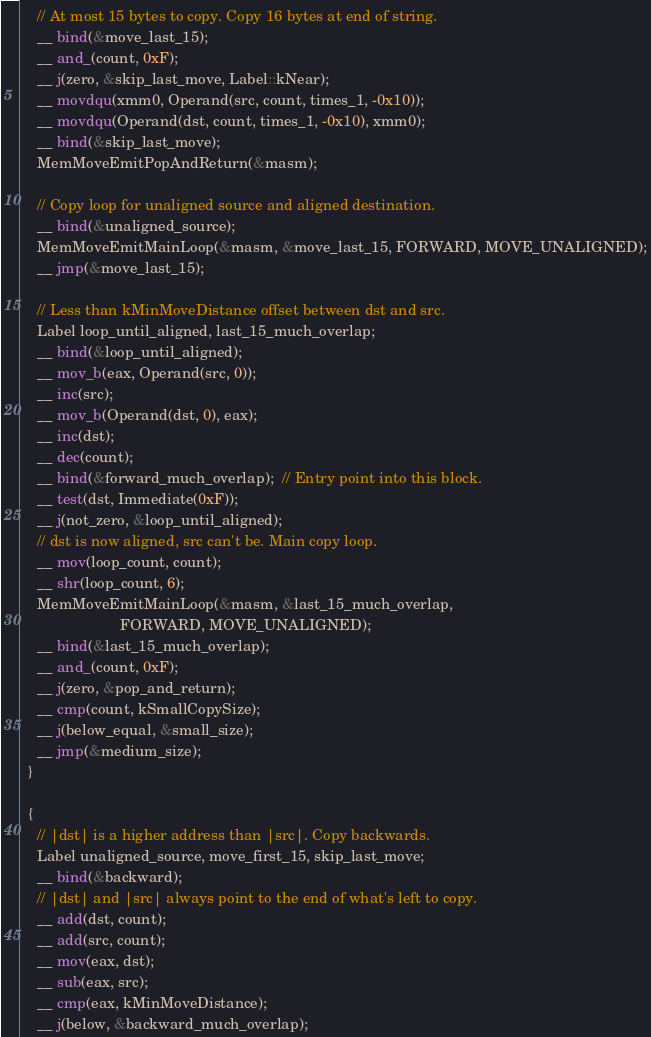Convert code to text. <code><loc_0><loc_0><loc_500><loc_500><_C++_>    // At most 15 bytes to copy. Copy 16 bytes at end of string.
    __ bind(&move_last_15);
    __ and_(count, 0xF);
    __ j(zero, &skip_last_move, Label::kNear);
    __ movdqu(xmm0, Operand(src, count, times_1, -0x10));
    __ movdqu(Operand(dst, count, times_1, -0x10), xmm0);
    __ bind(&skip_last_move);
    MemMoveEmitPopAndReturn(&masm);

    // Copy loop for unaligned source and aligned destination.
    __ bind(&unaligned_source);
    MemMoveEmitMainLoop(&masm, &move_last_15, FORWARD, MOVE_UNALIGNED);
    __ jmp(&move_last_15);

    // Less than kMinMoveDistance offset between dst and src.
    Label loop_until_aligned, last_15_much_overlap;
    __ bind(&loop_until_aligned);
    __ mov_b(eax, Operand(src, 0));
    __ inc(src);
    __ mov_b(Operand(dst, 0), eax);
    __ inc(dst);
    __ dec(count);
    __ bind(&forward_much_overlap);  // Entry point into this block.
    __ test(dst, Immediate(0xF));
    __ j(not_zero, &loop_until_aligned);
    // dst is now aligned, src can't be. Main copy loop.
    __ mov(loop_count, count);
    __ shr(loop_count, 6);
    MemMoveEmitMainLoop(&masm, &last_15_much_overlap,
                        FORWARD, MOVE_UNALIGNED);
    __ bind(&last_15_much_overlap);
    __ and_(count, 0xF);
    __ j(zero, &pop_and_return);
    __ cmp(count, kSmallCopySize);
    __ j(below_equal, &small_size);
    __ jmp(&medium_size);
  }

  {
    // |dst| is a higher address than |src|. Copy backwards.
    Label unaligned_source, move_first_15, skip_last_move;
    __ bind(&backward);
    // |dst| and |src| always point to the end of what's left to copy.
    __ add(dst, count);
    __ add(src, count);
    __ mov(eax, dst);
    __ sub(eax, src);
    __ cmp(eax, kMinMoveDistance);
    __ j(below, &backward_much_overlap);</code> 